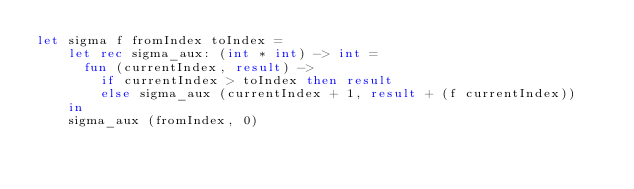Convert code to text. <code><loc_0><loc_0><loc_500><loc_500><_OCaml_>let sigma f fromIndex toIndex =
    let rec sigma_aux: (int * int) -> int =
      fun (currentIndex, result) ->
        if currentIndex > toIndex then result
        else sigma_aux (currentIndex + 1, result + (f currentIndex))
    in
    sigma_aux (fromIndex, 0)
</code> 